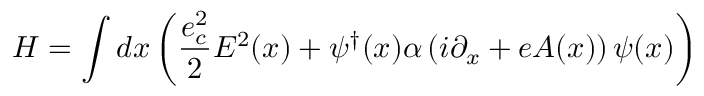Convert formula to latex. <formula><loc_0><loc_0><loc_500><loc_500>H = \int d x \left ( \frac { e _ { c } ^ { 2 } } { 2 } E ^ { 2 } ( x ) + \psi ^ { \dagger } ( x ) \alpha \left ( i \partial _ { x } + e A ( x ) \right ) \psi ( x ) \right )</formula> 